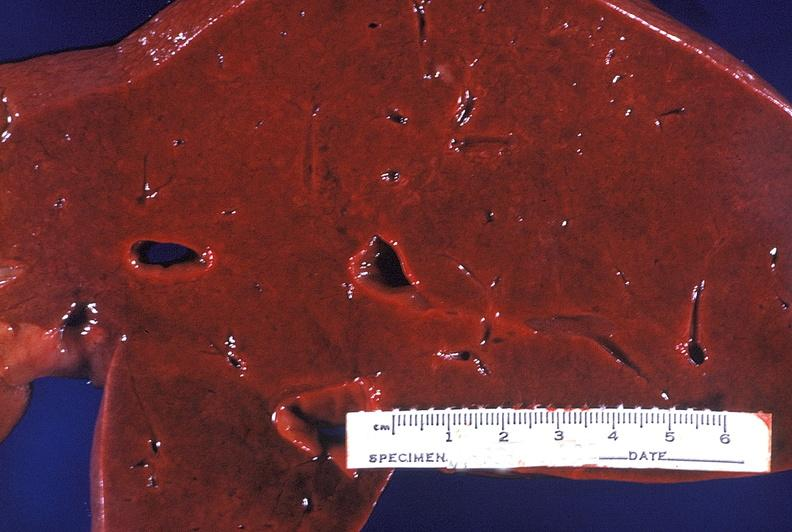s hepatobiliary present?
Answer the question using a single word or phrase. Yes 